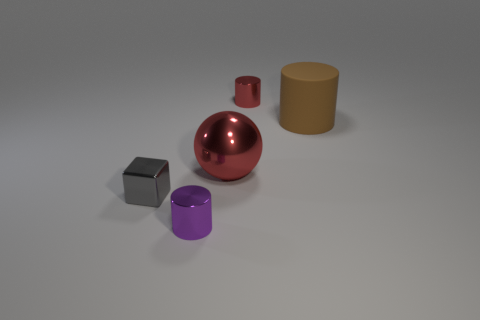Are there any small red shiny things on the right side of the large metal thing?
Ensure brevity in your answer.  Yes. There is a tiny gray object left of the large red metallic ball; what number of big cylinders are right of it?
Offer a terse response. 1. There is a purple cylinder that is the same size as the red cylinder; what material is it?
Give a very brief answer. Metal. How many other objects are there of the same material as the big red object?
Provide a succinct answer. 3. How many blocks are to the left of the big metallic object?
Make the answer very short. 1. How many cylinders are matte objects or small gray things?
Provide a short and direct response. 1. There is a object that is behind the gray cube and on the left side of the red metallic cylinder; what size is it?
Give a very brief answer. Large. What number of other things are there of the same color as the big metallic object?
Your answer should be very brief. 1. Is the material of the brown thing the same as the red object in front of the big cylinder?
Your response must be concise. No. What number of things are either objects that are behind the big red metal sphere or small metallic cylinders?
Provide a short and direct response. 3. 